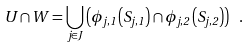<formula> <loc_0><loc_0><loc_500><loc_500>U \cap W = \bigcup _ { j \in J } \left ( \phi _ { j , 1 } \left ( S _ { j , 1 } \right ) \cap \phi _ { j , 2 } \left ( S _ { j , 2 } \right ) \right ) \ .</formula> 